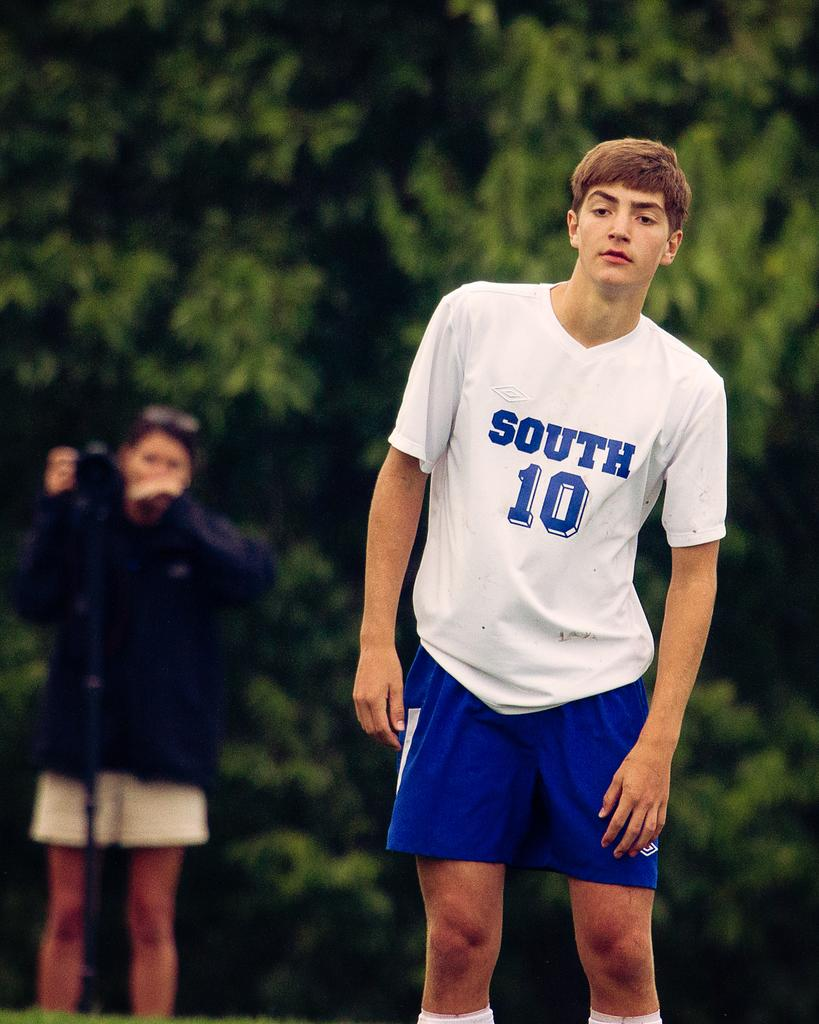<image>
Summarize the visual content of the image. a south 10 shirt on a person in white 